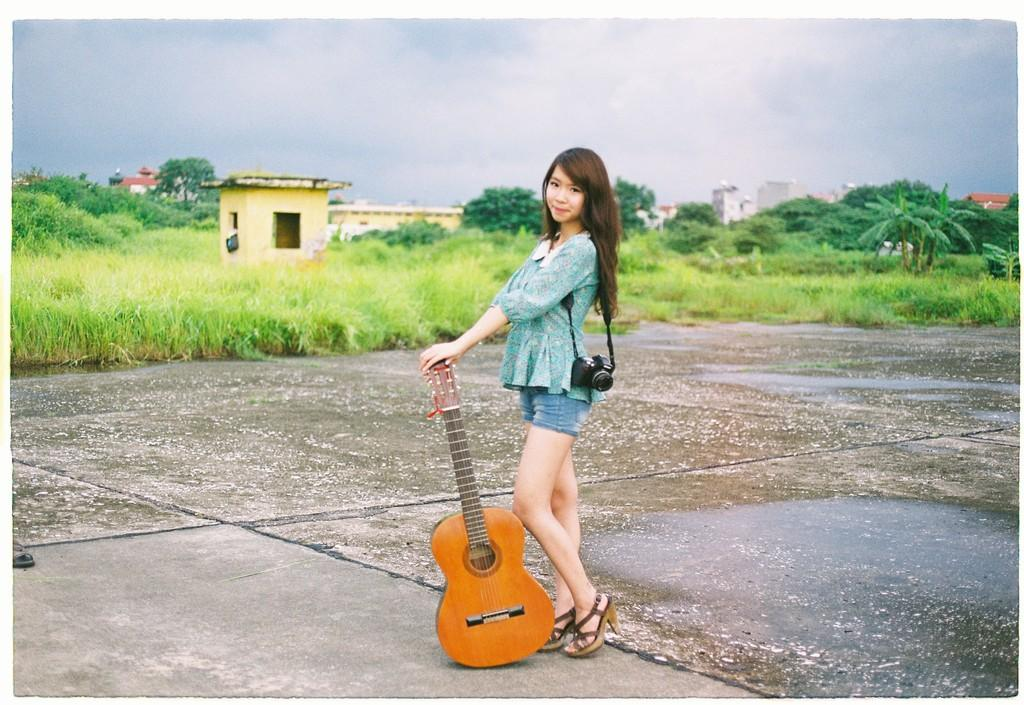Where is the person in the image located? The person is standing outside of the city. What is the person holding in the image? The person is holding a guitar. What is the person's facial expression in the image? The person is smiling. What is the person wearing in the image? The person is wearing a camera. What can be seen in the background of the image? Trees, buildings, and the sky are visible in the background. What type of pest can be seen crawling on the guitar in the image? There are no pests visible in the image, and the guitar is not being crawled on by any insects or animals. What is the title of the song the person is playing on the guitar in the image? The image does not provide any information about the song being played on the guitar, so it is impossible to determine the title. 